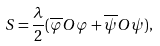Convert formula to latex. <formula><loc_0><loc_0><loc_500><loc_500>S = \frac { \lambda } { 2 } ( \overline { \varphi } O \varphi + \overline { \psi } O \psi ) ,</formula> 